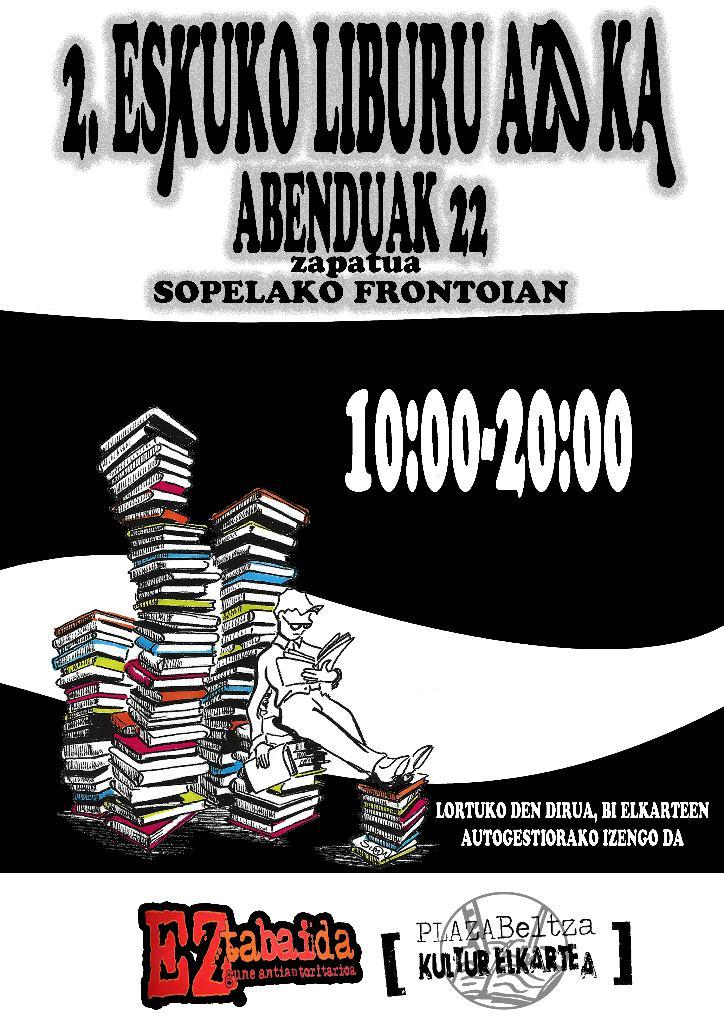<image>
Share a concise interpretation of the image provided. Poster that has the number 2 next to the word ESKUKO.. 